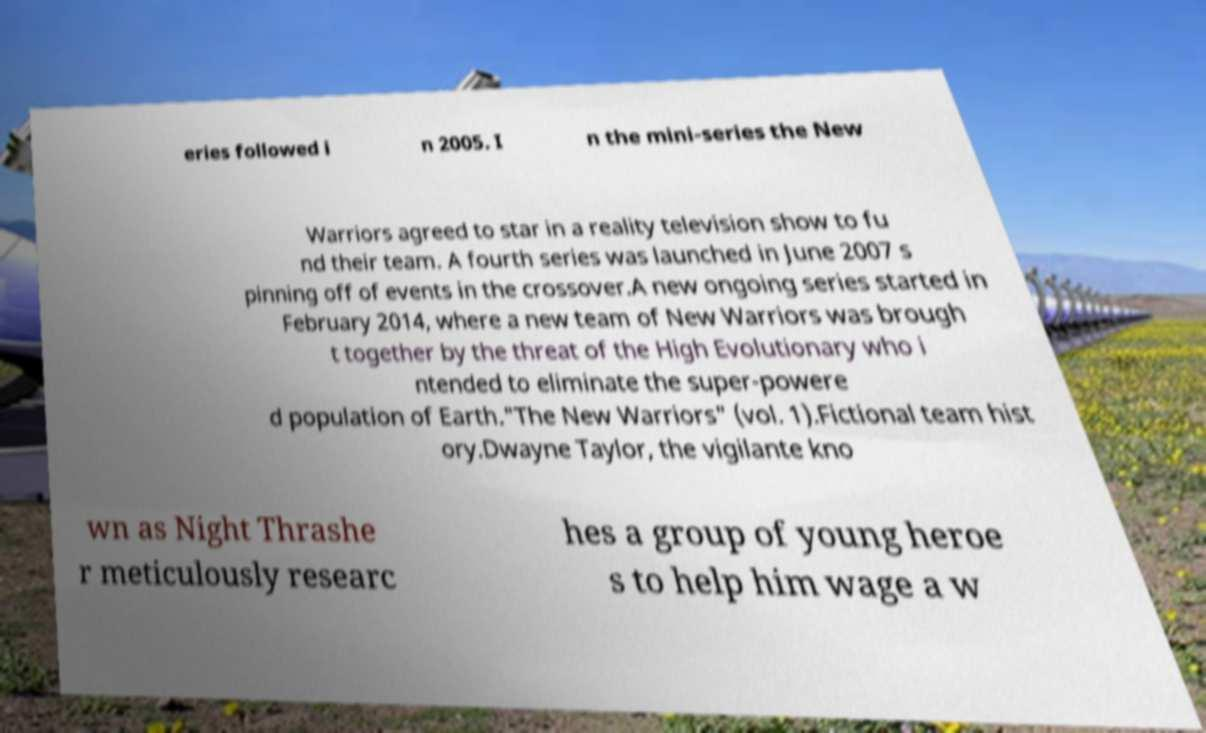What messages or text are displayed in this image? I need them in a readable, typed format. eries followed i n 2005. I n the mini-series the New Warriors agreed to star in a reality television show to fu nd their team. A fourth series was launched in June 2007 s pinning off of events in the crossover.A new ongoing series started in February 2014, where a new team of New Warriors was brough t together by the threat of the High Evolutionary who i ntended to eliminate the super-powere d population of Earth."The New Warriors" (vol. 1).Fictional team hist ory.Dwayne Taylor, the vigilante kno wn as Night Thrashe r meticulously researc hes a group of young heroe s to help him wage a w 